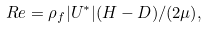<formula> <loc_0><loc_0><loc_500><loc_500>R e = \rho _ { f } | U ^ { * } | ( H - D ) / ( 2 \mu ) ,</formula> 